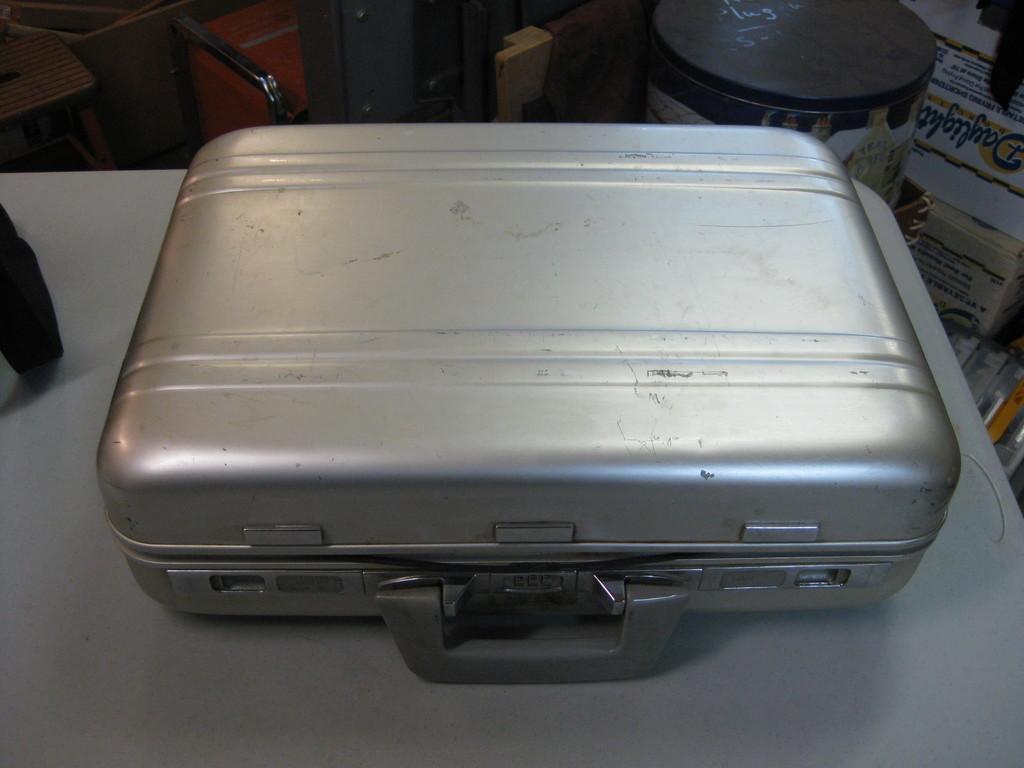Describe this image in one or two sentences. In this image there is a briefcase placed in a table and in back ground there is a box, hoarding. 